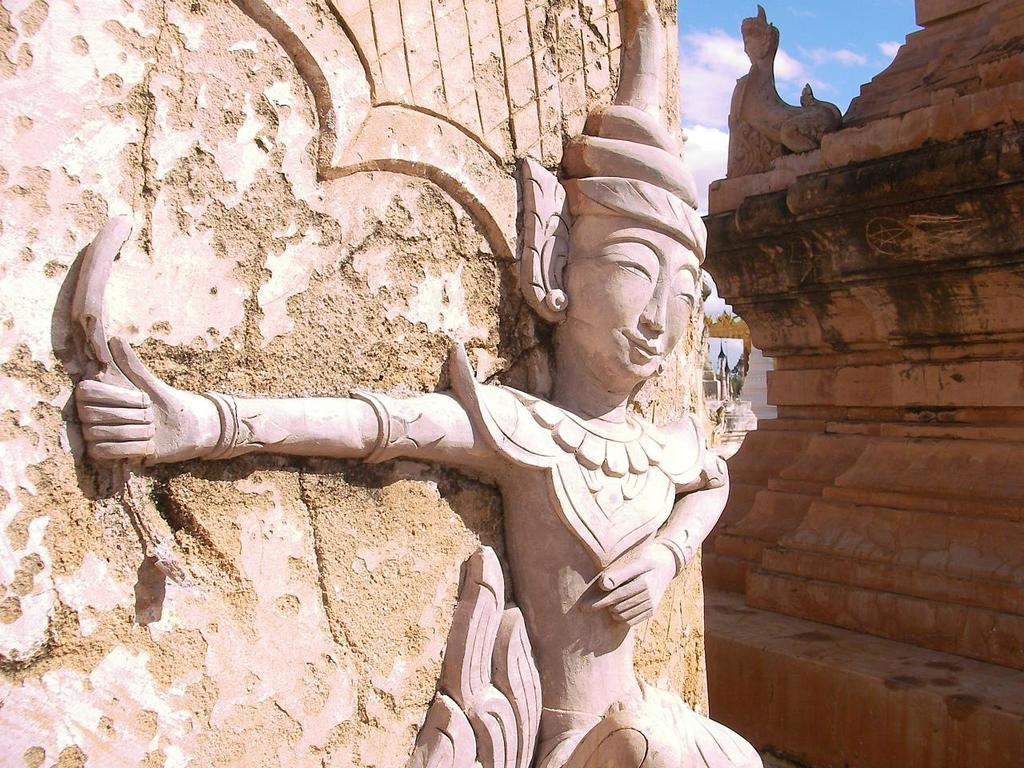What is on the wall in the image? There is a sculpture on the wall in the image. What type of structure can be seen in the image? There is a building in the image. Are there any other sculptures visible in the image? Yes, there is another sculpture on the building in the image. Can you see any clovers growing near the building in the image? There are no clovers visible in the image. The image does not show a cemetery or any indication of a need for one. 